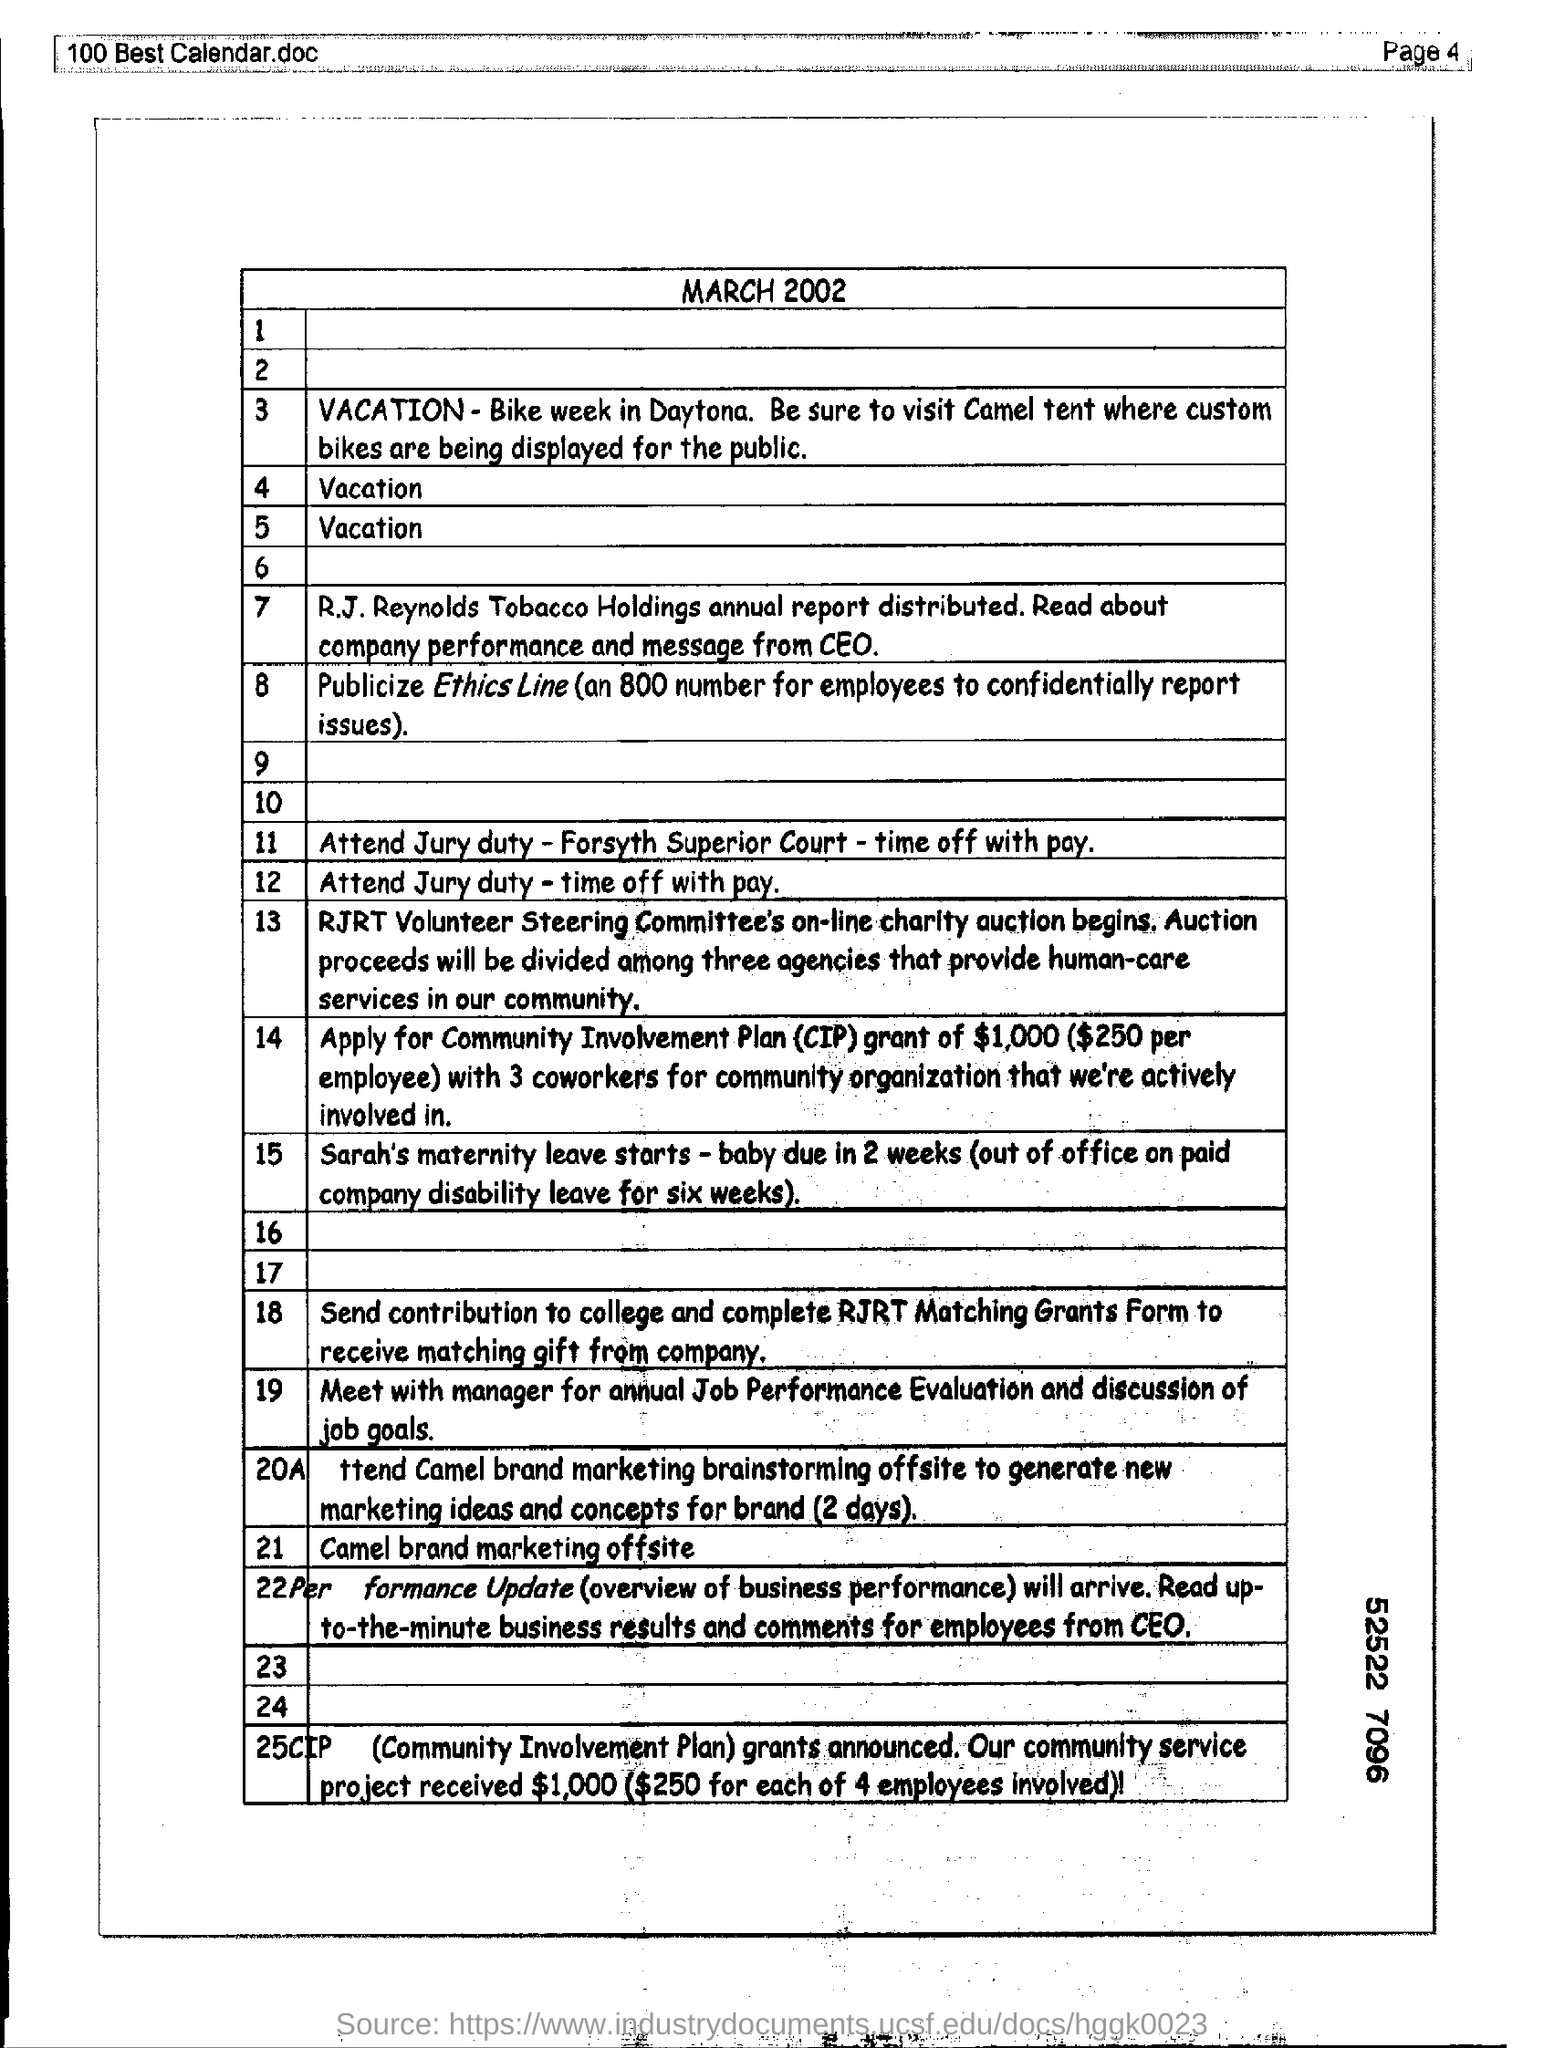Identify some key points in this picture. The document named '100 Best Calendar.doc' is mentioned in the header of the page. You have been assigned to attend jury duty for the Forsyth Superior Court, and you will be compensated with paid time off for this service. The page number written in the header is 4. The document heading is March 2002. 